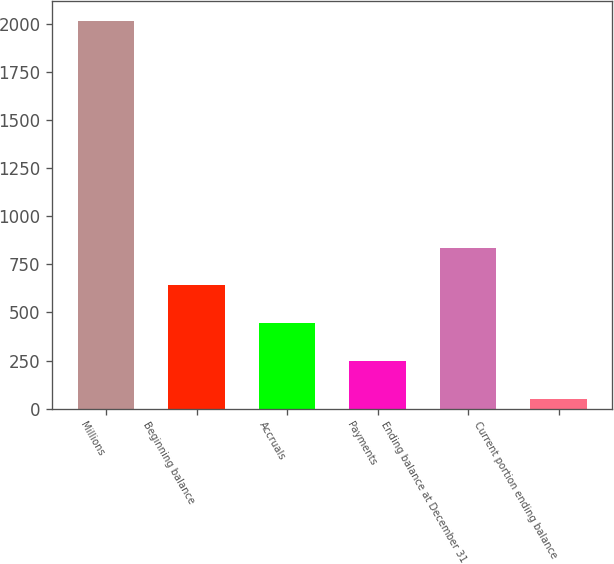Convert chart to OTSL. <chart><loc_0><loc_0><loc_500><loc_500><bar_chart><fcel>Millions<fcel>Beginning balance<fcel>Accruals<fcel>Payments<fcel>Ending balance at December 31<fcel>Current portion ending balance<nl><fcel>2015<fcel>640.9<fcel>444.6<fcel>248.3<fcel>837.2<fcel>52<nl></chart> 